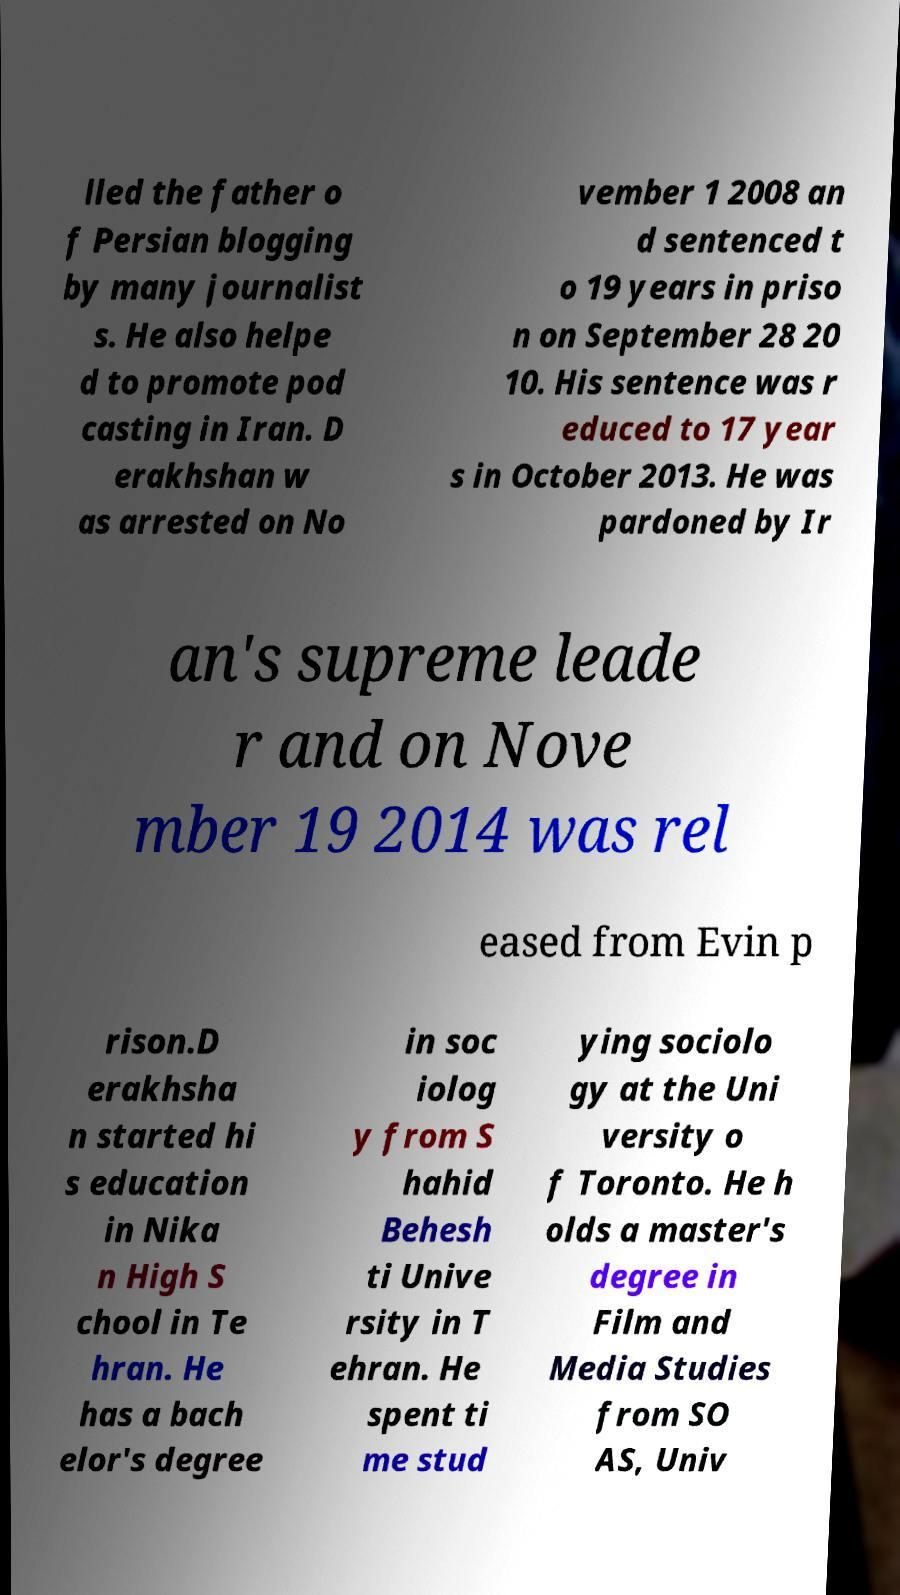Please identify and transcribe the text found in this image. lled the father o f Persian blogging by many journalist s. He also helpe d to promote pod casting in Iran. D erakhshan w as arrested on No vember 1 2008 an d sentenced t o 19 years in priso n on September 28 20 10. His sentence was r educed to 17 year s in October 2013. He was pardoned by Ir an's supreme leade r and on Nove mber 19 2014 was rel eased from Evin p rison.D erakhsha n started hi s education in Nika n High S chool in Te hran. He has a bach elor's degree in soc iolog y from S hahid Behesh ti Unive rsity in T ehran. He spent ti me stud ying sociolo gy at the Uni versity o f Toronto. He h olds a master's degree in Film and Media Studies from SO AS, Univ 